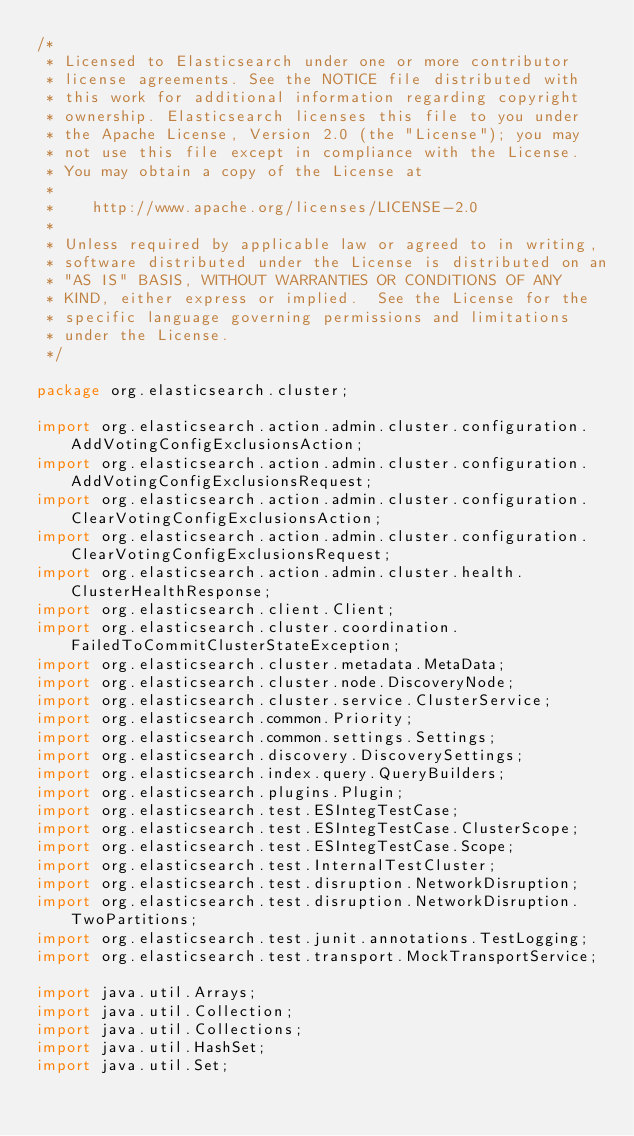Convert code to text. <code><loc_0><loc_0><loc_500><loc_500><_Java_>/*
 * Licensed to Elasticsearch under one or more contributor
 * license agreements. See the NOTICE file distributed with
 * this work for additional information regarding copyright
 * ownership. Elasticsearch licenses this file to you under
 * the Apache License, Version 2.0 (the "License"); you may
 * not use this file except in compliance with the License.
 * You may obtain a copy of the License at
 *
 *    http://www.apache.org/licenses/LICENSE-2.0
 *
 * Unless required by applicable law or agreed to in writing,
 * software distributed under the License is distributed on an
 * "AS IS" BASIS, WITHOUT WARRANTIES OR CONDITIONS OF ANY
 * KIND, either express or implied.  See the License for the
 * specific language governing permissions and limitations
 * under the License.
 */

package org.elasticsearch.cluster;

import org.elasticsearch.action.admin.cluster.configuration.AddVotingConfigExclusionsAction;
import org.elasticsearch.action.admin.cluster.configuration.AddVotingConfigExclusionsRequest;
import org.elasticsearch.action.admin.cluster.configuration.ClearVotingConfigExclusionsAction;
import org.elasticsearch.action.admin.cluster.configuration.ClearVotingConfigExclusionsRequest;
import org.elasticsearch.action.admin.cluster.health.ClusterHealthResponse;
import org.elasticsearch.client.Client;
import org.elasticsearch.cluster.coordination.FailedToCommitClusterStateException;
import org.elasticsearch.cluster.metadata.MetaData;
import org.elasticsearch.cluster.node.DiscoveryNode;
import org.elasticsearch.cluster.service.ClusterService;
import org.elasticsearch.common.Priority;
import org.elasticsearch.common.settings.Settings;
import org.elasticsearch.discovery.DiscoverySettings;
import org.elasticsearch.index.query.QueryBuilders;
import org.elasticsearch.plugins.Plugin;
import org.elasticsearch.test.ESIntegTestCase;
import org.elasticsearch.test.ESIntegTestCase.ClusterScope;
import org.elasticsearch.test.ESIntegTestCase.Scope;
import org.elasticsearch.test.InternalTestCluster;
import org.elasticsearch.test.disruption.NetworkDisruption;
import org.elasticsearch.test.disruption.NetworkDisruption.TwoPartitions;
import org.elasticsearch.test.junit.annotations.TestLogging;
import org.elasticsearch.test.transport.MockTransportService;

import java.util.Arrays;
import java.util.Collection;
import java.util.Collections;
import java.util.HashSet;
import java.util.Set;</code> 